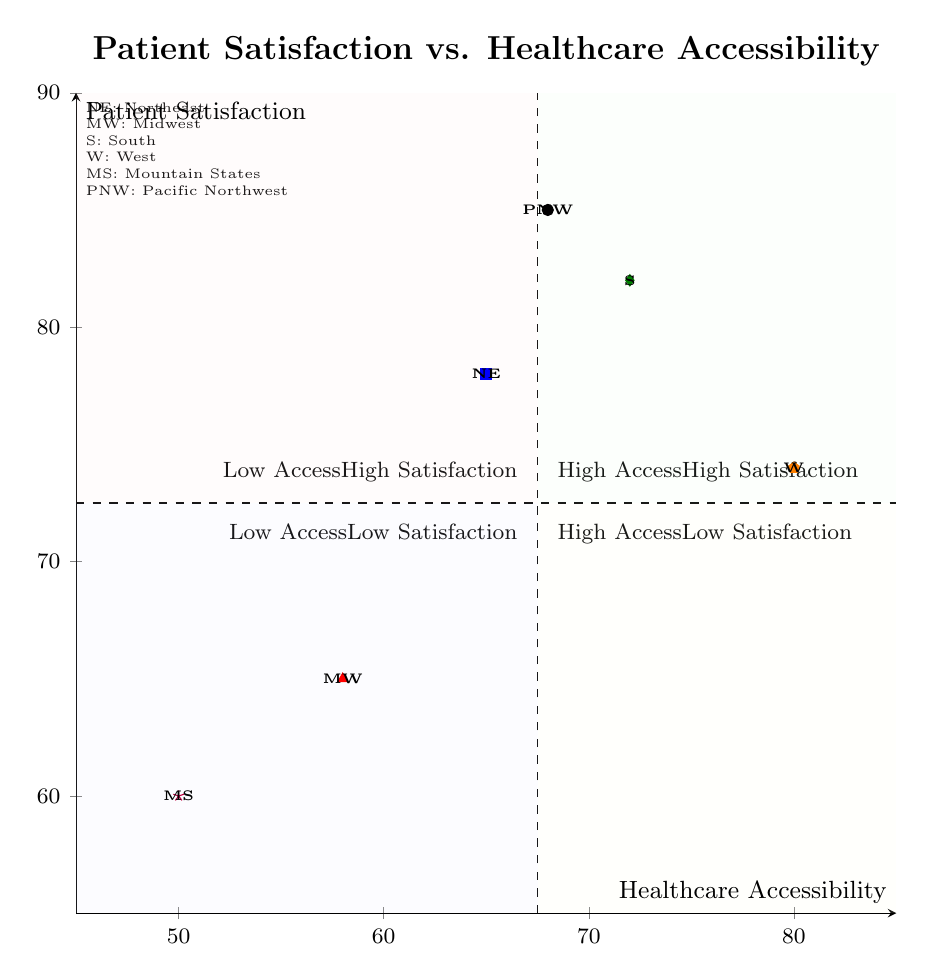What is the patient satisfaction level in the South region? The diagram includes the South region, which is positioned with a patient satisfaction value of 82.
Answer: 82 How many regions have high accessibility and high satisfaction? By examining the diagram, two regions (South and West) fall into the High Access and High Satisfaction quadrant, indicated by their positions in that area.
Answer: 2 Which region has the lowest healthcare accessibility? The Mountain States region is shown in the diagram with the lowest healthcare accessibility score of 50.
Answer: 50 What region has the highest patient satisfaction score? The Pacific Northwest is indicated as having the highest patient satisfaction score of 85, as per its position in the diagram.
Answer: 85 In which quadrant does the Midwest region fall? The Midwest region falls into the Low Access and Low Satisfaction quadrant based on its accessibility score of 58 and satisfaction score of 65, which places it in the corresponding area of the chart.
Answer: Low Access Low Satisfaction Which region is suggested to have difficulties due to long waiting times despite good patient satisfaction? The Northeast region is highlighted, indicating that it has a high patient satisfaction score of 78, but the note mentions long waiting times affecting accessibility.
Answer: Northeast How does patient satisfaction in the Mountain States compare to the West? The Mountain States has a patient satisfaction score of 60, while the West has a score of 74, showing that the West scores higher in patient satisfaction compared to the Mountain States.
Answer: West What can be inferred about the Pacific Northwest's healthcare accessibility? The Pacific Northwest has a healthcare accessibility score of 68, indicating that while it has excellent patient feedback, it has variable accessibility especially between urban and rural areas.
Answer: Variable Access What quadrant includes regions with high healthcare accessibility but low patient satisfaction? The Low Access and High Satisfaction quadrant, where the Northeast is found, suggests that high accessibility does not guarantee patient satisfaction, indicated by that specific quadrant placement.
Answer: High Access Low Satisfaction 